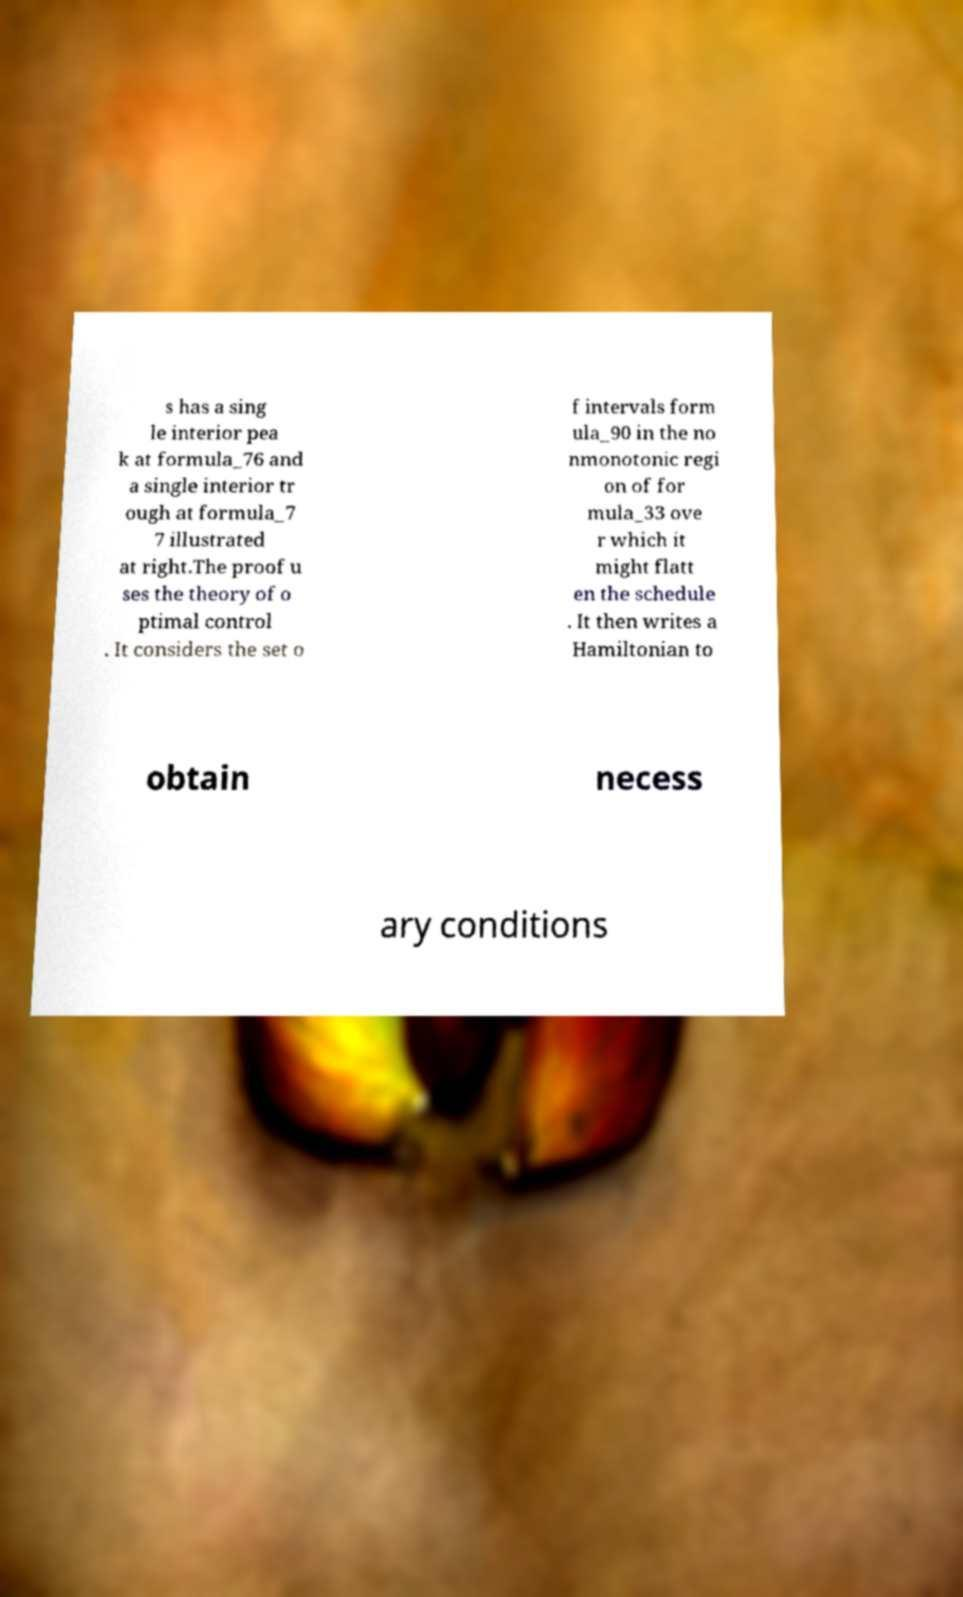Please identify and transcribe the text found in this image. s has a sing le interior pea k at formula_76 and a single interior tr ough at formula_7 7 illustrated at right.The proof u ses the theory of o ptimal control . It considers the set o f intervals form ula_90 in the no nmonotonic regi on of for mula_33 ove r which it might flatt en the schedule . It then writes a Hamiltonian to obtain necess ary conditions 